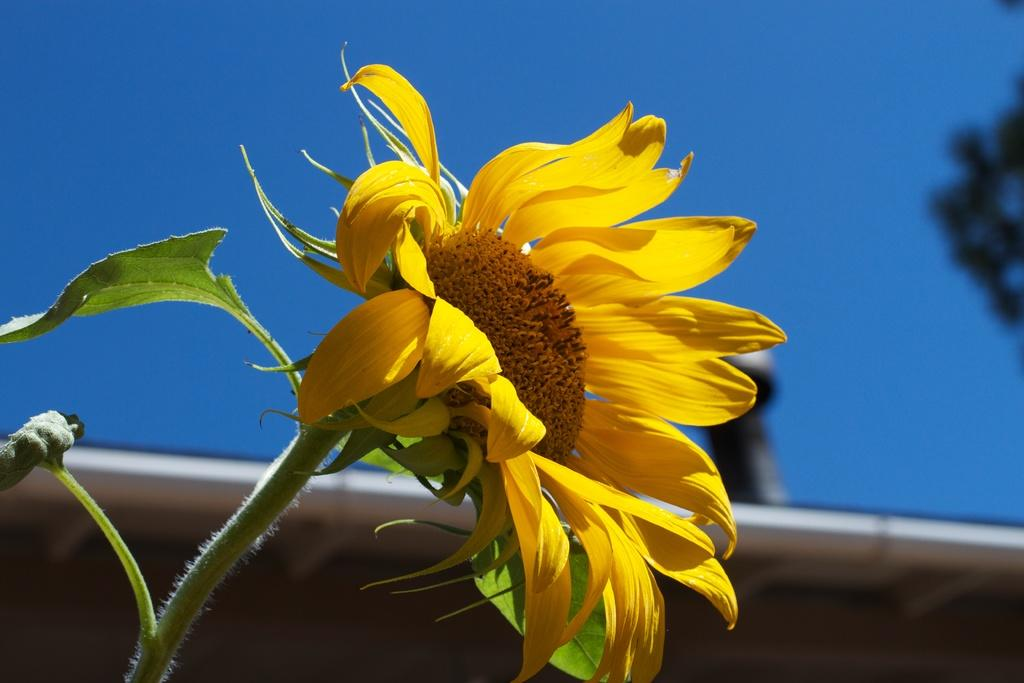What is the main subject in the center of the image? There is a sunflower in the center of the image. What structure can be seen at the bottom of the image? There is a roof visible at the bottom of the image. How many wings are visible on the sunflower in the image? Sunflowers do not have wings, so none are visible in the image. What type of meal is being prepared in the image? There is no indication of a meal being prepared in the image; it primarily features a sunflower and a roof. 